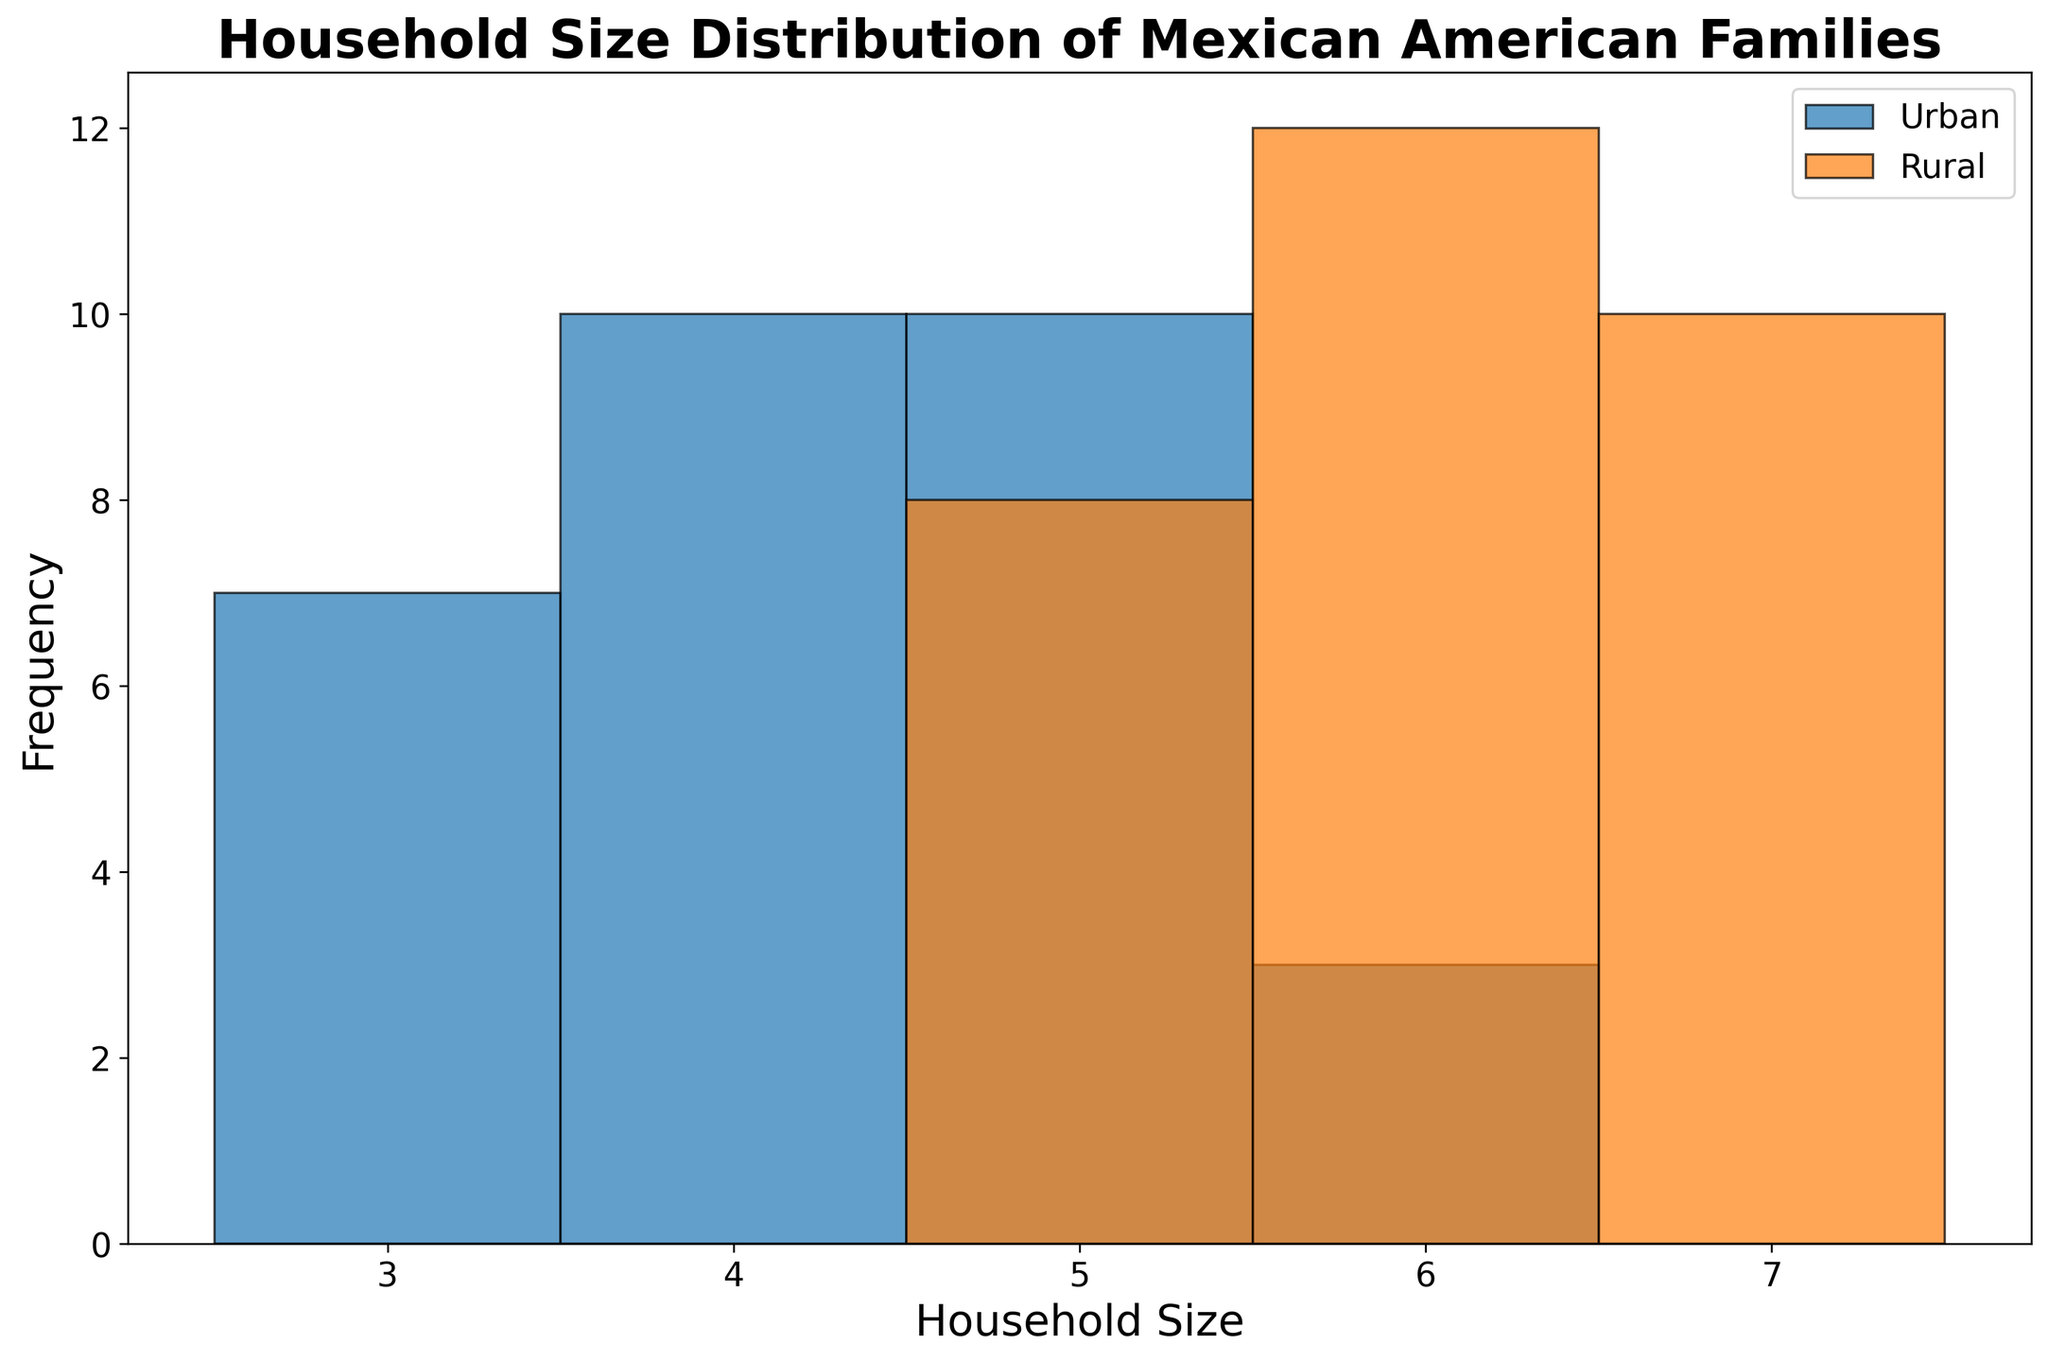What is the most common household size for Urban families? The histogram for Urban households shows the tallest bar occurring at household size 4, indicating it's the most frequent.
Answer: 4 Which location has a higher frequency of households with size 6? By comparing the heights of the bars corresponding to 6 in both histograms, the Rural area shows a higher bar, indicating a higher frequency.
Answer: Rural How many different household sizes are represented in the Urban data? By looking at the Urban histogram, we count the number of distinct bars, which are 3, 4, 5, and 6.
Answer: 4 Which household size in the Rural area has the lowest frequency? The shortest bar in the Rural histogram corresponds to the household size 5.
Answer: 5 Is the household size distribution for Urban areas more uniform or skewed compared to Rural areas? The Urban areas show a more uniform distribution with similar bar heights for sizes 3, 4, and 5, while the Rural areas show a skew towards higher sizes, with large bars at 6 and 7.
Answer: More uniform What's the difference in frequency between the most common household size in Urban and the most common size in Rural areas? The most common household size for Urban is 4, and for Rural, it is 6. The Urban bar for size 4 is approximately 8, and the Rural bar for size 6 is approximately 10. The difference is
Answer: 2 What proportion of Urban families have a household size of 5? There are 30 Urban data points, and the bar for household size 5 is 6. Therefore, 6/30 = 0.2
Answer: 0.2 For which household size(s) do Urban and Rural areas have the same frequency? By visually comparing the height of the bars, household size 5 has similar bar heights for both Urban and Rural areas.
Answer: 5 